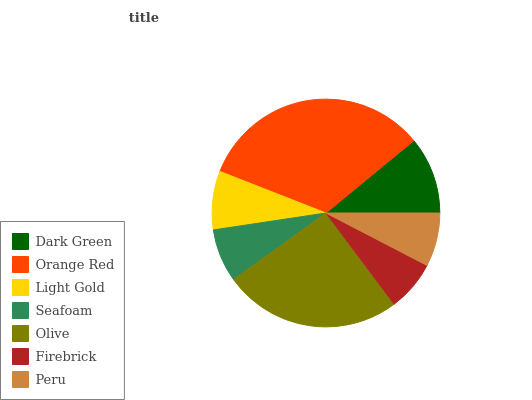Is Firebrick the minimum?
Answer yes or no. Yes. Is Orange Red the maximum?
Answer yes or no. Yes. Is Light Gold the minimum?
Answer yes or no. No. Is Light Gold the maximum?
Answer yes or no. No. Is Orange Red greater than Light Gold?
Answer yes or no. Yes. Is Light Gold less than Orange Red?
Answer yes or no. Yes. Is Light Gold greater than Orange Red?
Answer yes or no. No. Is Orange Red less than Light Gold?
Answer yes or no. No. Is Light Gold the high median?
Answer yes or no. Yes. Is Light Gold the low median?
Answer yes or no. Yes. Is Orange Red the high median?
Answer yes or no. No. Is Olive the low median?
Answer yes or no. No. 